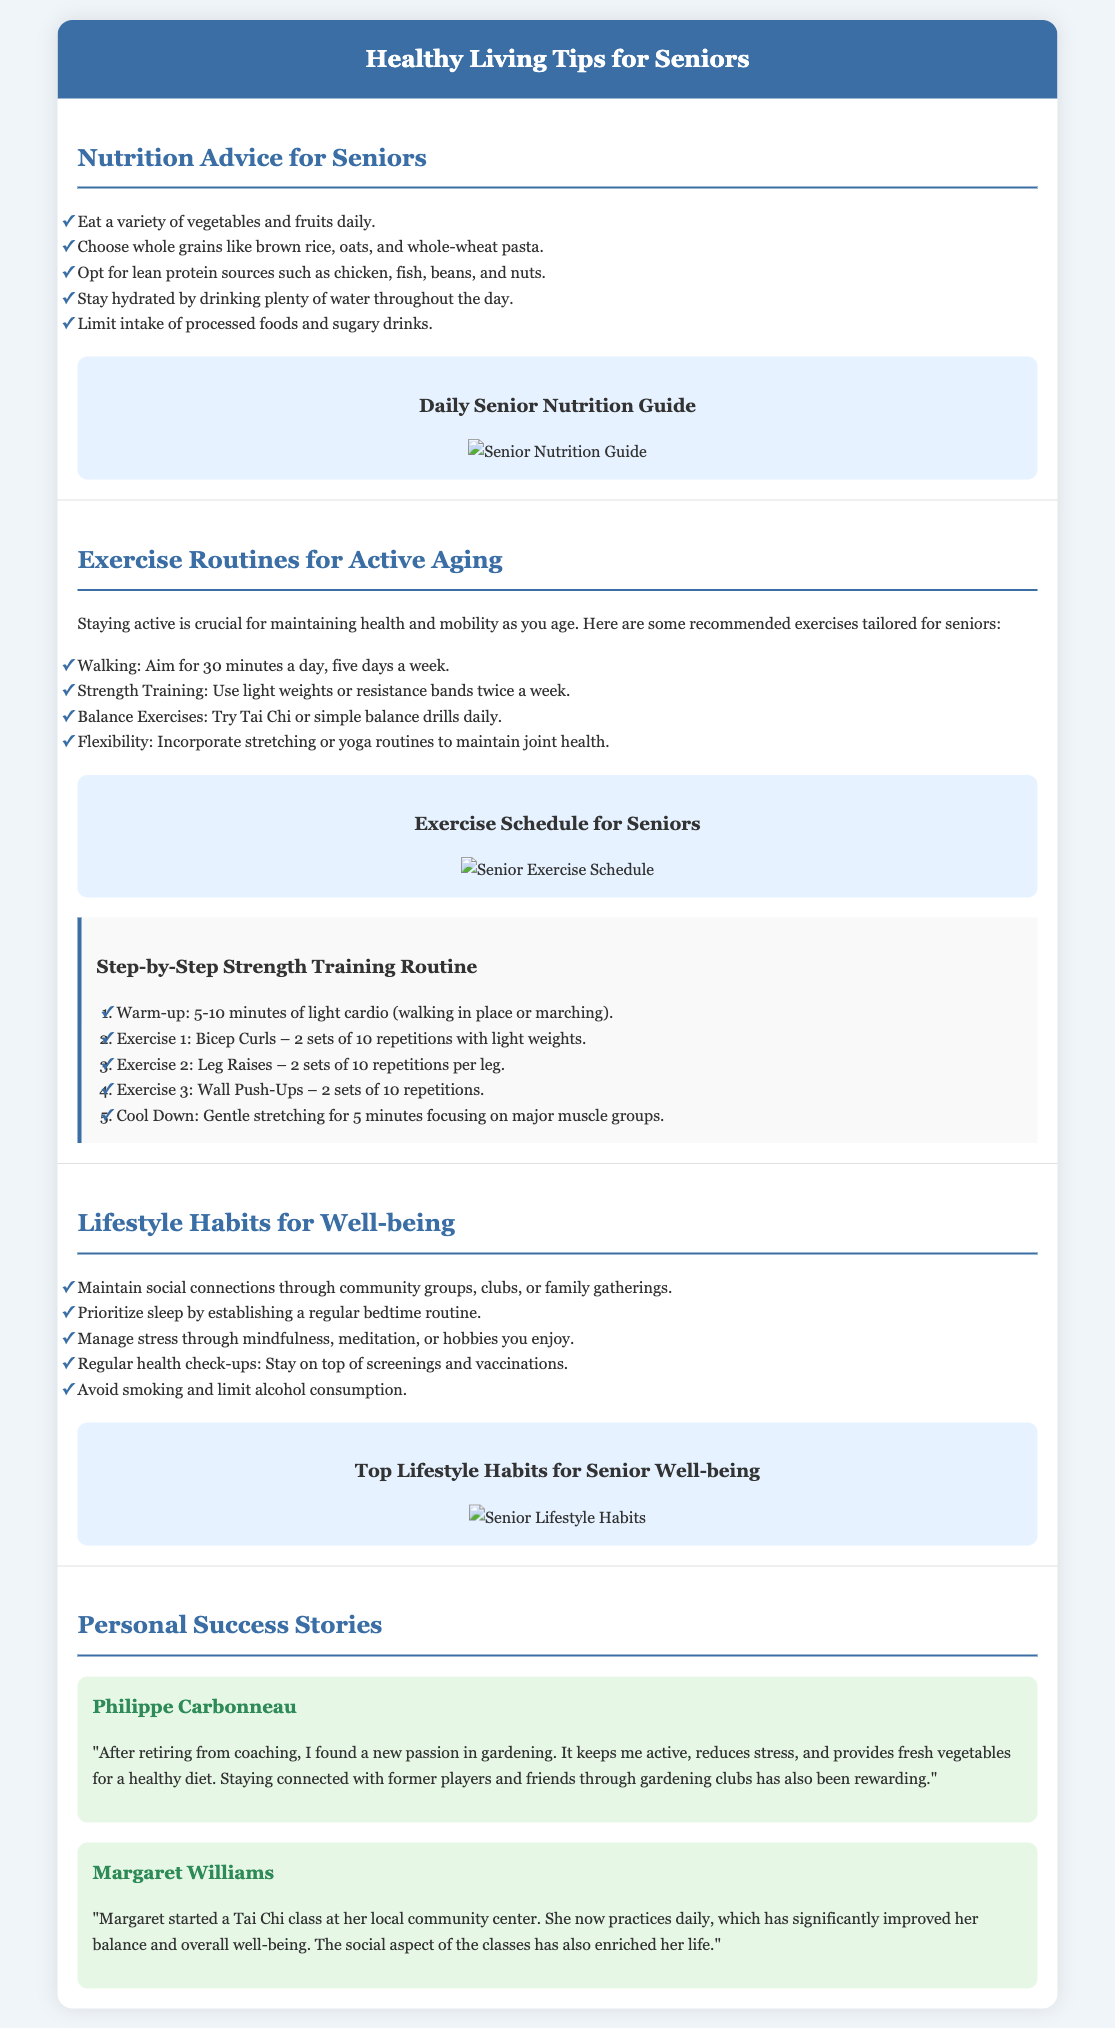What are the daily recommended minutes for walking? The document suggests aiming for 30 minutes a day of walking, five days a week.
Answer: 30 minutes Who shares a personal success story in the document? The document includes success stories from Philippe Carbonneau and Margaret Williams.
Answer: Philippe Carbonneau, Margaret Williams What type of exercise is suggested to improve balance? The document recommends Tai Chi or simple balance drills for maintaining balance.
Answer: Tai Chi How often should strength training be performed according to the flyer? The document indicates that strength training should be done twice a week.
Answer: Twice a week What is a recommended source of lean protein for seniors? The document lists chicken, fish, beans, and nuts as lean protein sources.
Answer: Chicken, fish, beans, nuts Which lifestyle habit is emphasized for managing stress? The document mentions mindfulness, meditation, or engaging in hobbies as stress management techniques.
Answer: Mindfulness, meditation, hobbies What color is the header of the flyer? The document states that the header background color is #3a6ea5 (a shade of blue).
Answer: Blue What is the title of the infographic in the nutrition section? The title of the infographic is "Daily Senior Nutrition Guide."
Answer: Daily Senior Nutrition Guide How many types of lifestyle habits are listed in the document? The document mentions five specific lifestyle habits for well-being.
Answer: Five 